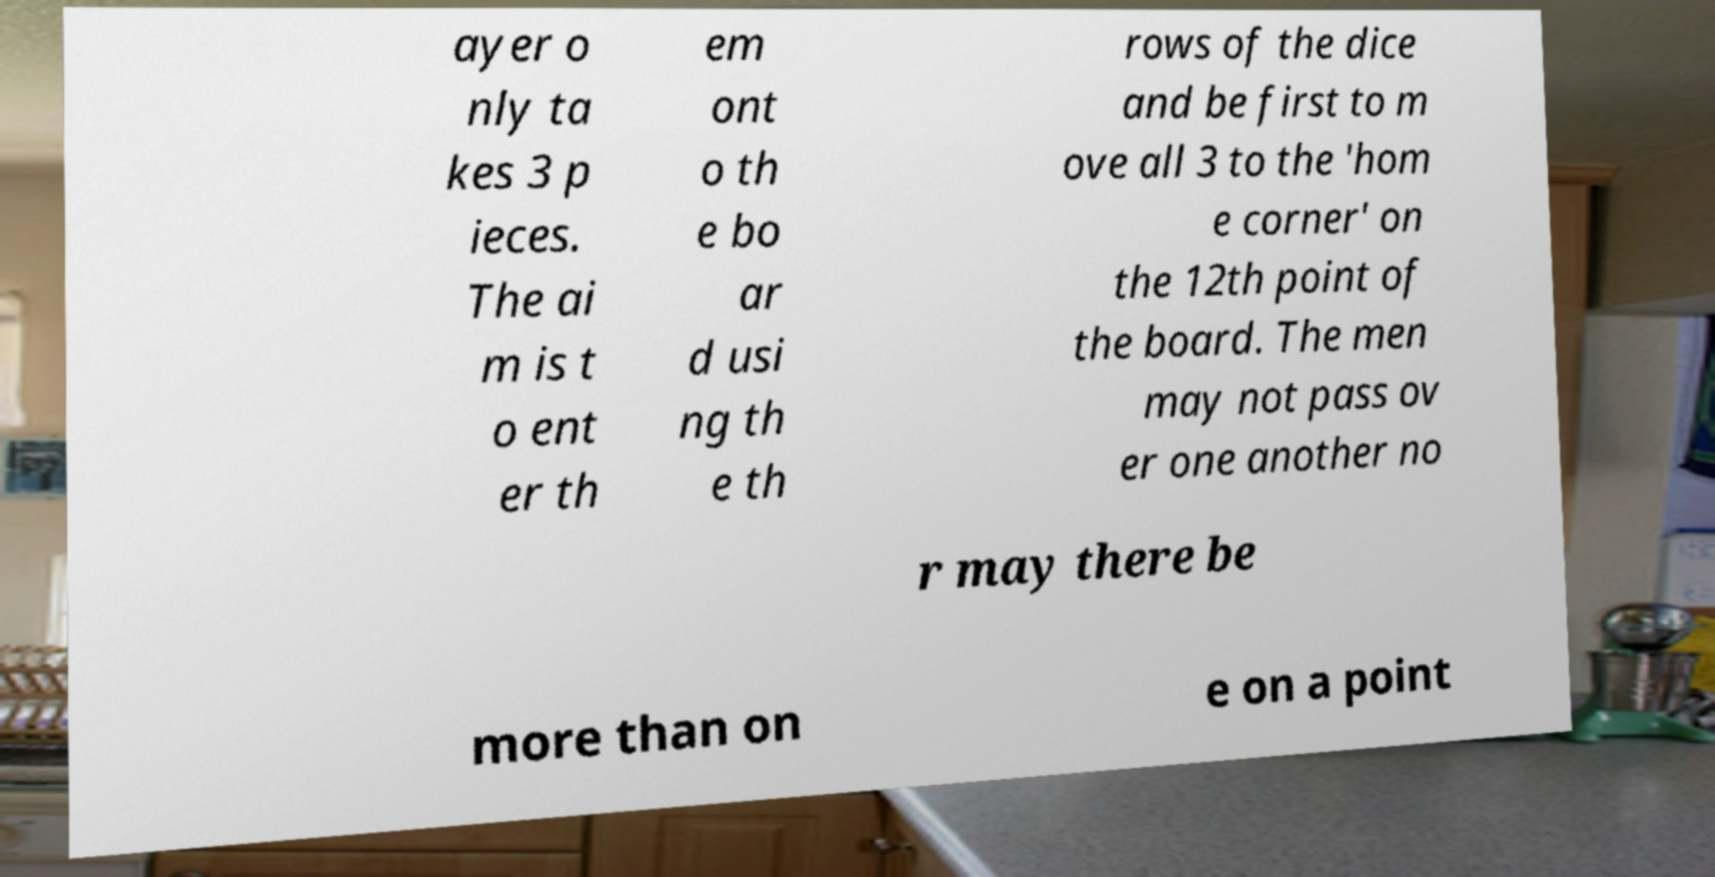Could you extract and type out the text from this image? ayer o nly ta kes 3 p ieces. The ai m is t o ent er th em ont o th e bo ar d usi ng th e th rows of the dice and be first to m ove all 3 to the 'hom e corner' on the 12th point of the board. The men may not pass ov er one another no r may there be more than on e on a point 